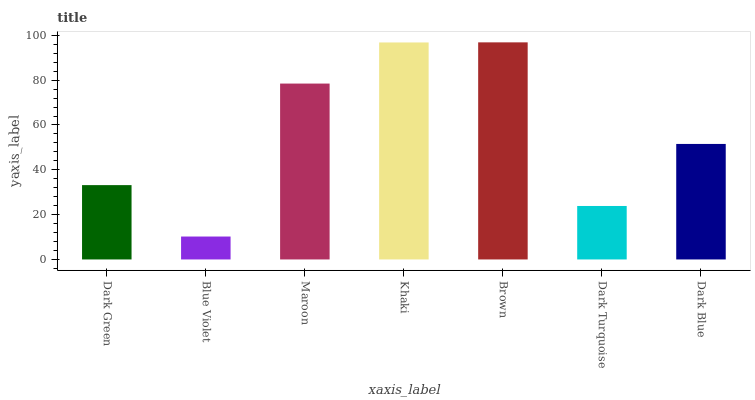Is Blue Violet the minimum?
Answer yes or no. Yes. Is Brown the maximum?
Answer yes or no. Yes. Is Maroon the minimum?
Answer yes or no. No. Is Maroon the maximum?
Answer yes or no. No. Is Maroon greater than Blue Violet?
Answer yes or no. Yes. Is Blue Violet less than Maroon?
Answer yes or no. Yes. Is Blue Violet greater than Maroon?
Answer yes or no. No. Is Maroon less than Blue Violet?
Answer yes or no. No. Is Dark Blue the high median?
Answer yes or no. Yes. Is Dark Blue the low median?
Answer yes or no. Yes. Is Dark Turquoise the high median?
Answer yes or no. No. Is Khaki the low median?
Answer yes or no. No. 